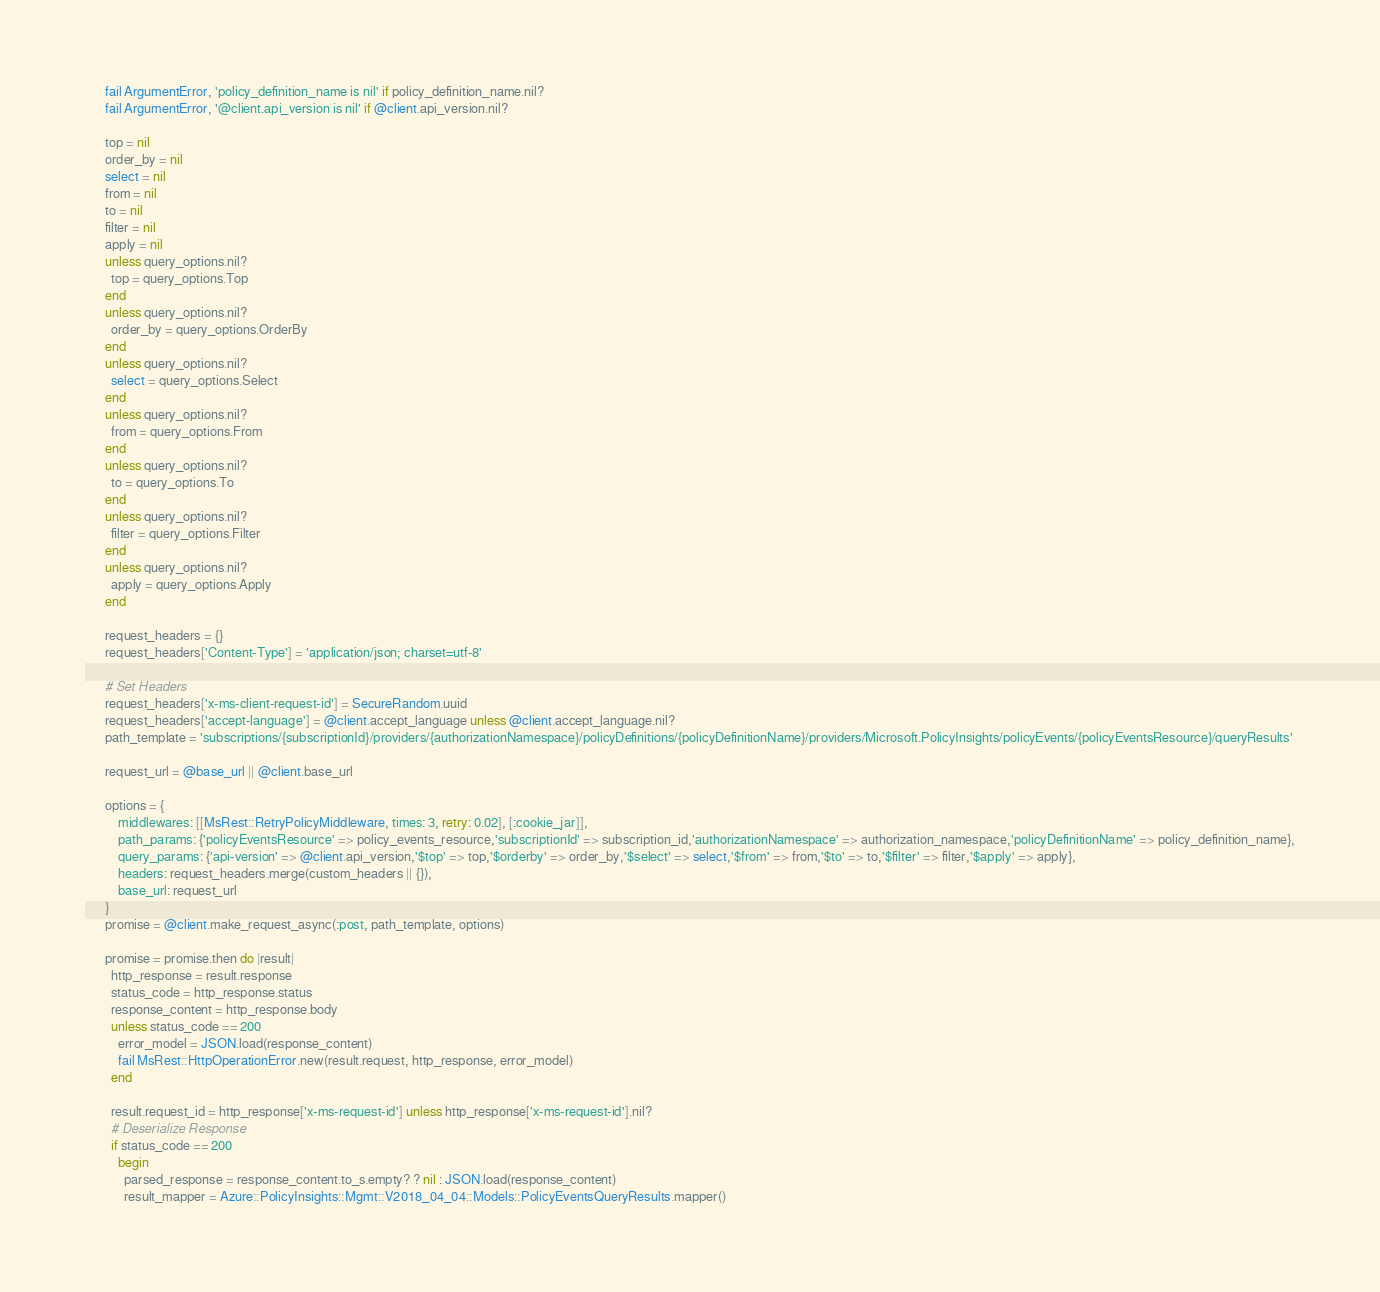Convert code to text. <code><loc_0><loc_0><loc_500><loc_500><_Ruby_>      fail ArgumentError, 'policy_definition_name is nil' if policy_definition_name.nil?
      fail ArgumentError, '@client.api_version is nil' if @client.api_version.nil?

      top = nil
      order_by = nil
      select = nil
      from = nil
      to = nil
      filter = nil
      apply = nil
      unless query_options.nil?
        top = query_options.Top
      end
      unless query_options.nil?
        order_by = query_options.OrderBy
      end
      unless query_options.nil?
        select = query_options.Select
      end
      unless query_options.nil?
        from = query_options.From
      end
      unless query_options.nil?
        to = query_options.To
      end
      unless query_options.nil?
        filter = query_options.Filter
      end
      unless query_options.nil?
        apply = query_options.Apply
      end

      request_headers = {}
      request_headers['Content-Type'] = 'application/json; charset=utf-8'

      # Set Headers
      request_headers['x-ms-client-request-id'] = SecureRandom.uuid
      request_headers['accept-language'] = @client.accept_language unless @client.accept_language.nil?
      path_template = 'subscriptions/{subscriptionId}/providers/{authorizationNamespace}/policyDefinitions/{policyDefinitionName}/providers/Microsoft.PolicyInsights/policyEvents/{policyEventsResource}/queryResults'

      request_url = @base_url || @client.base_url

      options = {
          middlewares: [[MsRest::RetryPolicyMiddleware, times: 3, retry: 0.02], [:cookie_jar]],
          path_params: {'policyEventsResource' => policy_events_resource,'subscriptionId' => subscription_id,'authorizationNamespace' => authorization_namespace,'policyDefinitionName' => policy_definition_name},
          query_params: {'api-version' => @client.api_version,'$top' => top,'$orderby' => order_by,'$select' => select,'$from' => from,'$to' => to,'$filter' => filter,'$apply' => apply},
          headers: request_headers.merge(custom_headers || {}),
          base_url: request_url
      }
      promise = @client.make_request_async(:post, path_template, options)

      promise = promise.then do |result|
        http_response = result.response
        status_code = http_response.status
        response_content = http_response.body
        unless status_code == 200
          error_model = JSON.load(response_content)
          fail MsRest::HttpOperationError.new(result.request, http_response, error_model)
        end

        result.request_id = http_response['x-ms-request-id'] unless http_response['x-ms-request-id'].nil?
        # Deserialize Response
        if status_code == 200
          begin
            parsed_response = response_content.to_s.empty? ? nil : JSON.load(response_content)
            result_mapper = Azure::PolicyInsights::Mgmt::V2018_04_04::Models::PolicyEventsQueryResults.mapper()</code> 